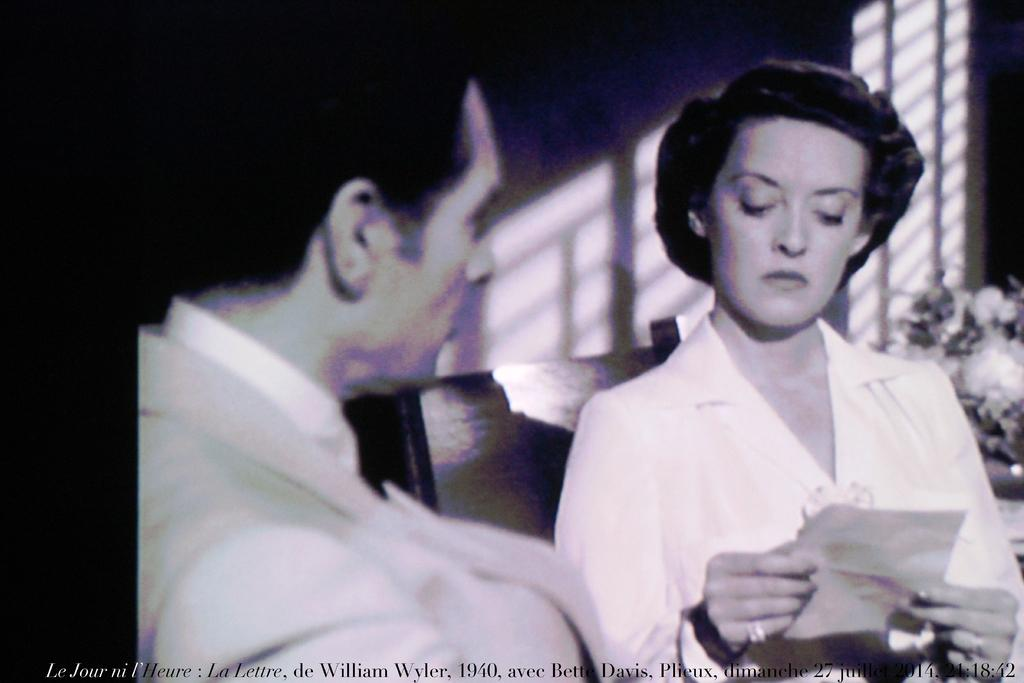What is the lady holding in the image? The lady is holding a paper in the image. Who is in the foreground of the image? There is a man in the foreground of the image. What can be found at the bottom side of the image? There is text at the bottom side of the image. What type of vegetation is visible in the background of the image? There are flowers in the background of the image. What color is the shirt worn by the owner of the alley in the image? There is no alley or owner mentioned in the image, and no one is wearing a shirt. How many geese are walking in the alley in the image? There is no alley or geese present in the image. 